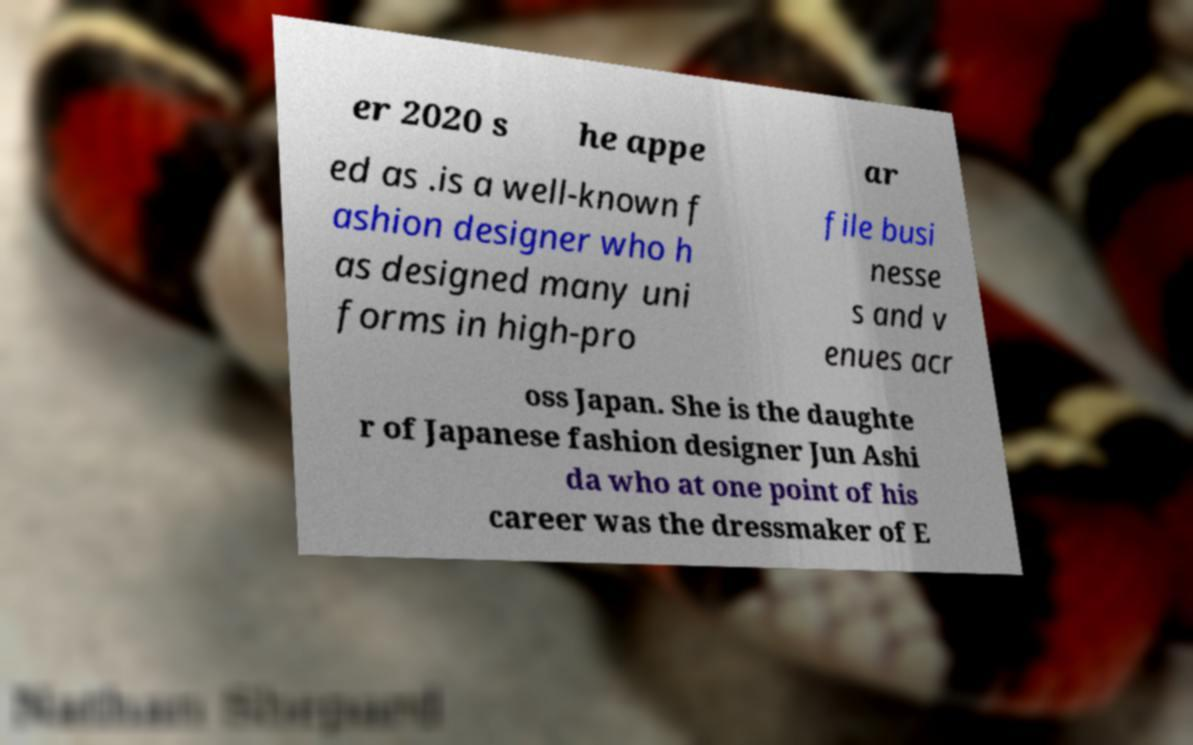What messages or text are displayed in this image? I need them in a readable, typed format. er 2020 s he appe ar ed as .is a well-known f ashion designer who h as designed many uni forms in high-pro file busi nesse s and v enues acr oss Japan. She is the daughte r of Japanese fashion designer Jun Ashi da who at one point of his career was the dressmaker of E 